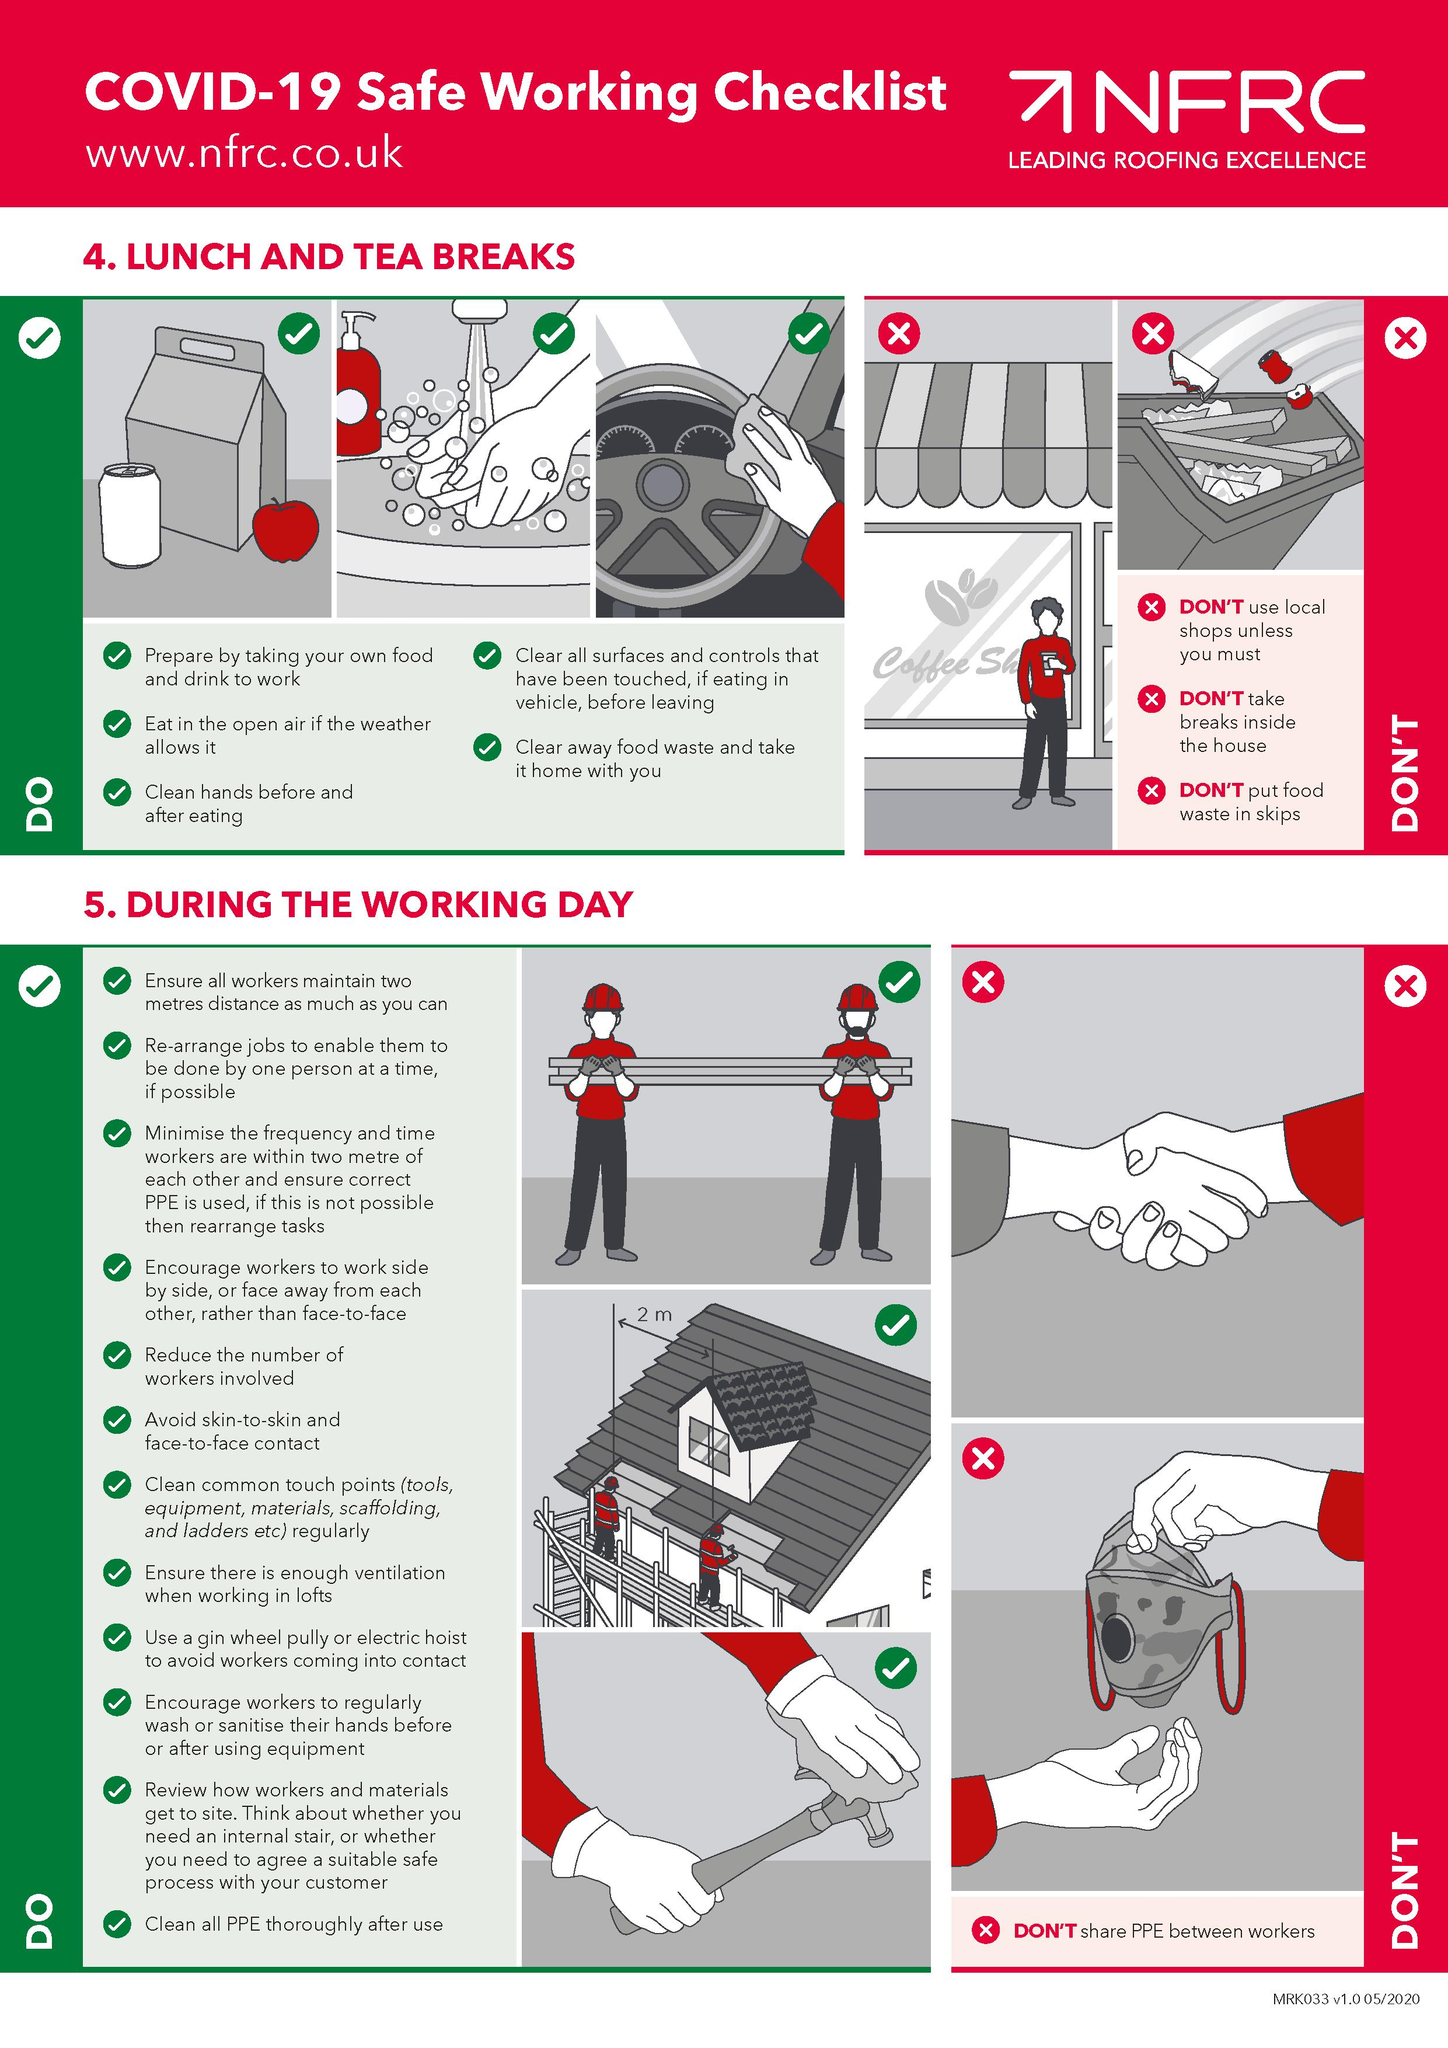Identify some key points in this picture. In the infographic, the second "Don't" listed is "Don't take breaks inside the house. There are three images listed under the heading "Lunch and Tea Breaks" in the infographic that depict examples of "Do's". The third DON'T listed in the infographic is not to put food waste in skips, instead it is recommended to compost it. The infographic lists a total of three images for "DOs" that are applicable during the working day. It is not appropriate to share personal protective equipment (PPE) between workers during the working day. 